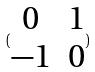Convert formula to latex. <formula><loc_0><loc_0><loc_500><loc_500>( \begin{matrix} 0 & 1 \\ - 1 & 0 \\ \end{matrix} )</formula> 